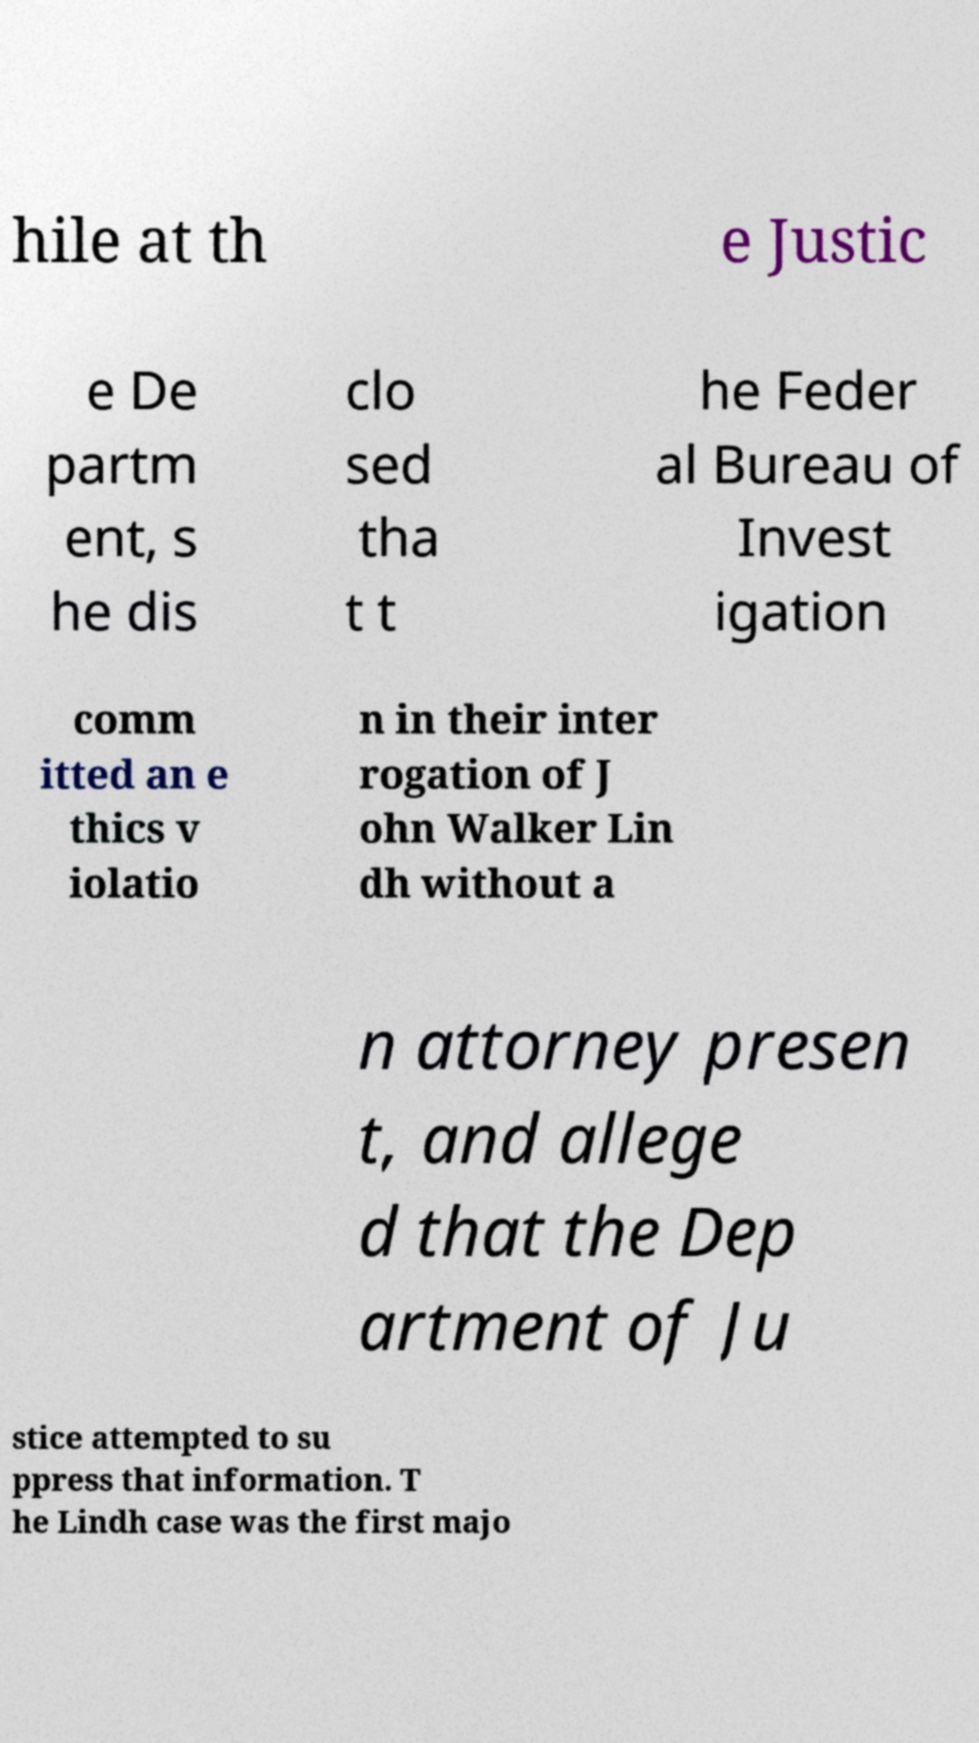There's text embedded in this image that I need extracted. Can you transcribe it verbatim? hile at th e Justic e De partm ent, s he dis clo sed tha t t he Feder al Bureau of Invest igation comm itted an e thics v iolatio n in their inter rogation of J ohn Walker Lin dh without a n attorney presen t, and allege d that the Dep artment of Ju stice attempted to su ppress that information. T he Lindh case was the first majo 